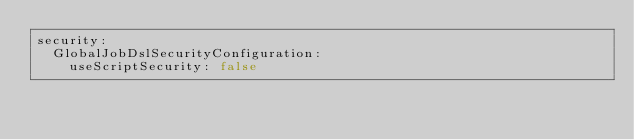Convert code to text. <code><loc_0><loc_0><loc_500><loc_500><_YAML_>security:
  GlobalJobDslSecurityConfiguration:
    useScriptSecurity: false</code> 